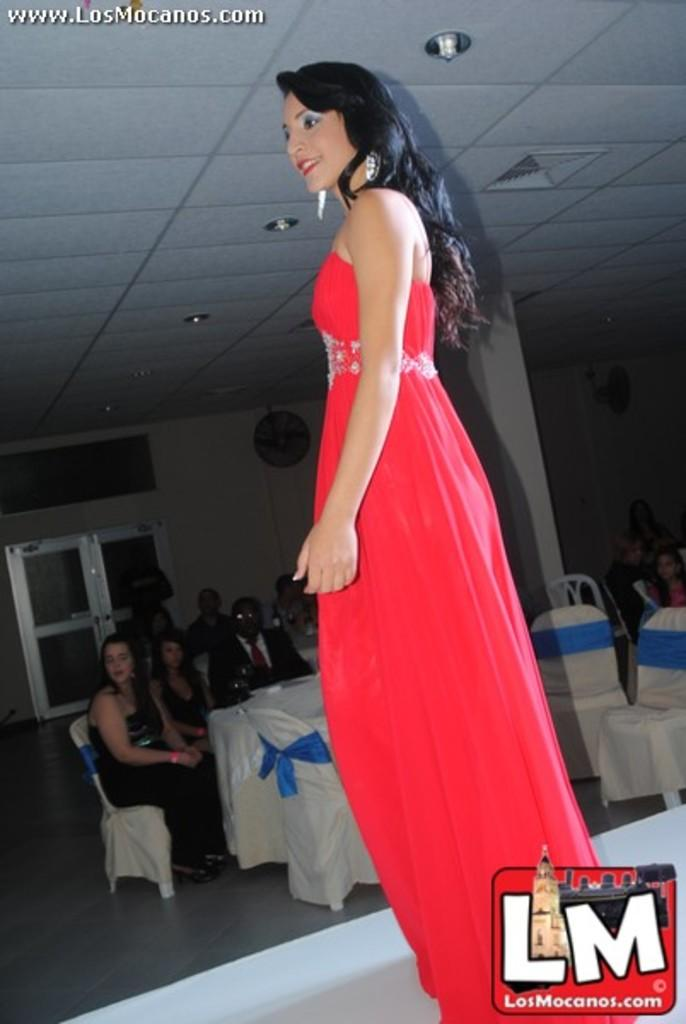Who is present in the image? There is a woman in the image. What is the woman wearing? The woman is wearing a red dress. What is the woman doing in the image? The woman is standing. What objects can be seen in the middle of the image? There are chairs in the middle of the image. What are some persons doing with the chairs? Some persons are sitting on the chairs. What can be seen at the top of the image? There are lights at the top of the image. What type of church is depicted in the image? There is no church present in the image. What religious symbols can be seen in the image? There are no religious symbols present in the image. 